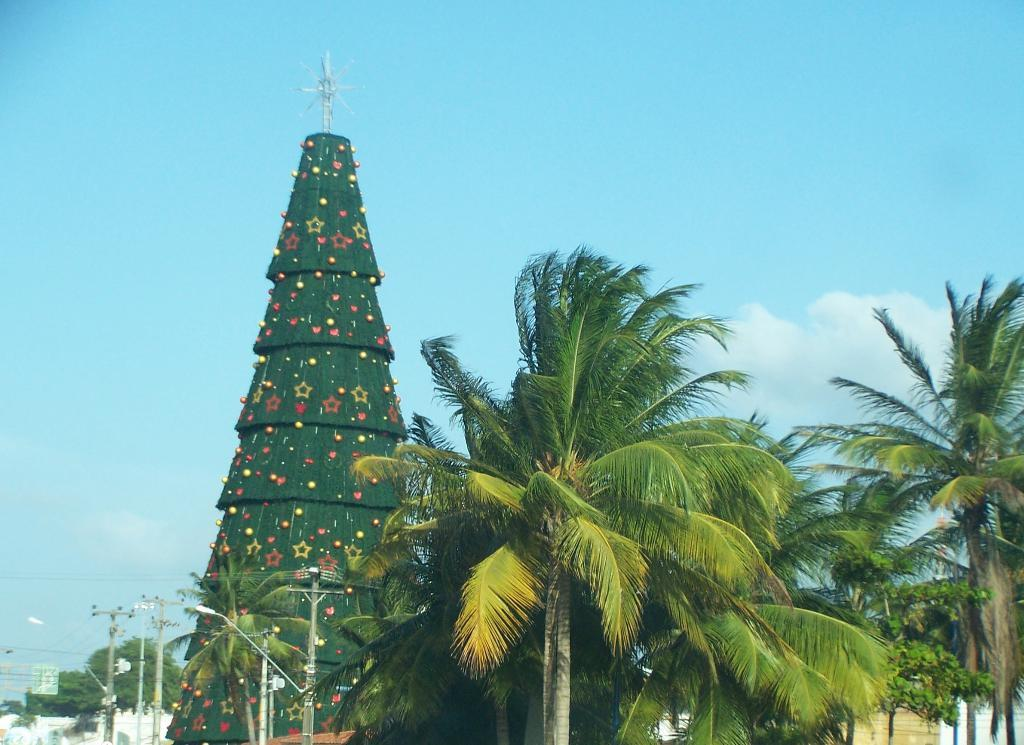What is the main subject in the center of the image? There is a depiction of a Christmas tree in the center of the image. What other natural elements can be seen in the image? There are trees in the image. What man-made structures are present in the image? There are electric poles in the image. What is visible at the top of the image? The sky is visible at the top of the image. What type of wave can be seen crashing on the shore in the image? There is no wave or shore present in the image; it features a Christmas tree, trees, electric poles, and the sky. 